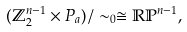<formula> <loc_0><loc_0><loc_500><loc_500>( \mathbb { Z } _ { 2 } ^ { n - 1 } \times P _ { a } ) / \sim _ { 0 } \cong \mathbb { R P } ^ { n - 1 } ,</formula> 